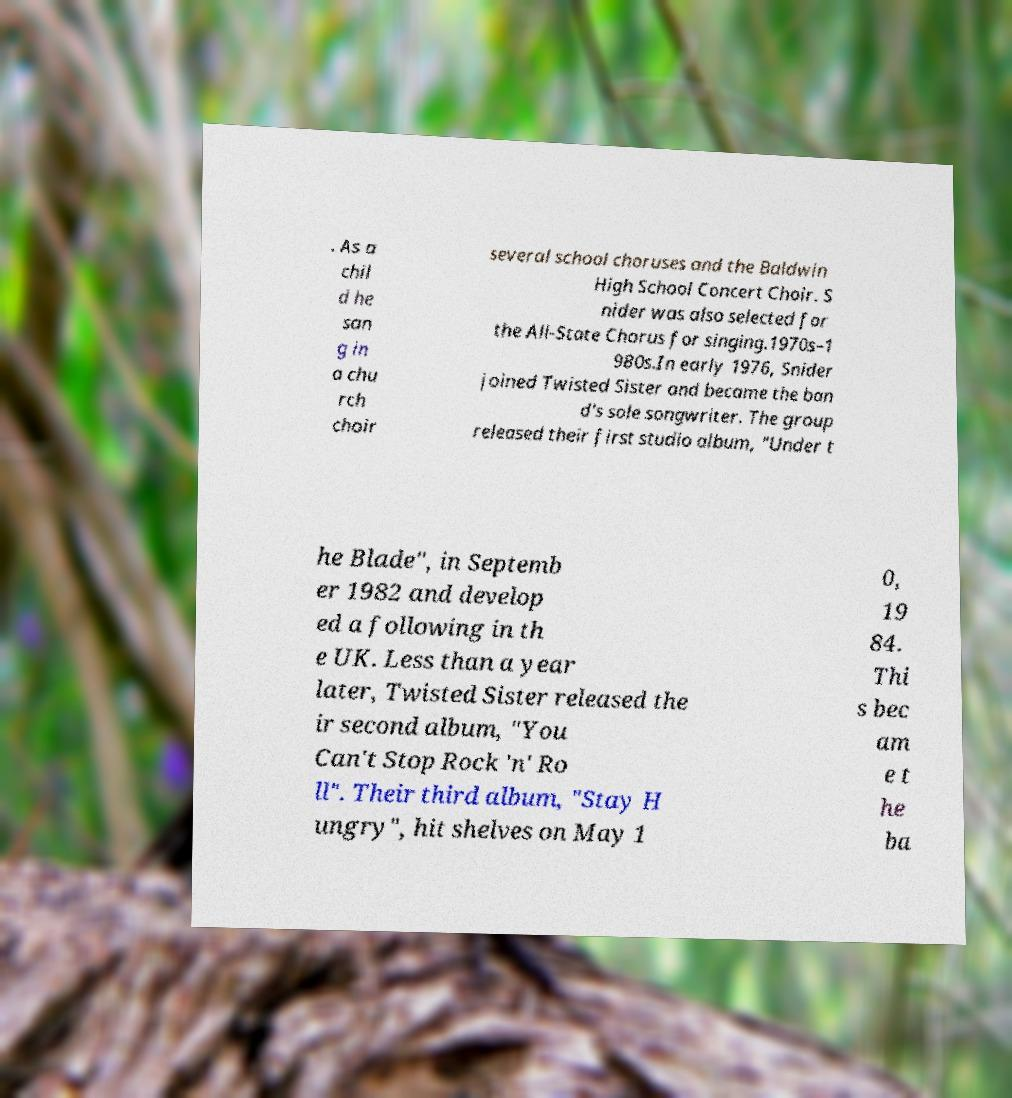What messages or text are displayed in this image? I need them in a readable, typed format. . As a chil d he san g in a chu rch choir several school choruses and the Baldwin High School Concert Choir. S nider was also selected for the All-State Chorus for singing.1970s–1 980s.In early 1976, Snider joined Twisted Sister and became the ban d's sole songwriter. The group released their first studio album, "Under t he Blade", in Septemb er 1982 and develop ed a following in th e UK. Less than a year later, Twisted Sister released the ir second album, "You Can't Stop Rock 'n' Ro ll". Their third album, "Stay H ungry", hit shelves on May 1 0, 19 84. Thi s bec am e t he ba 